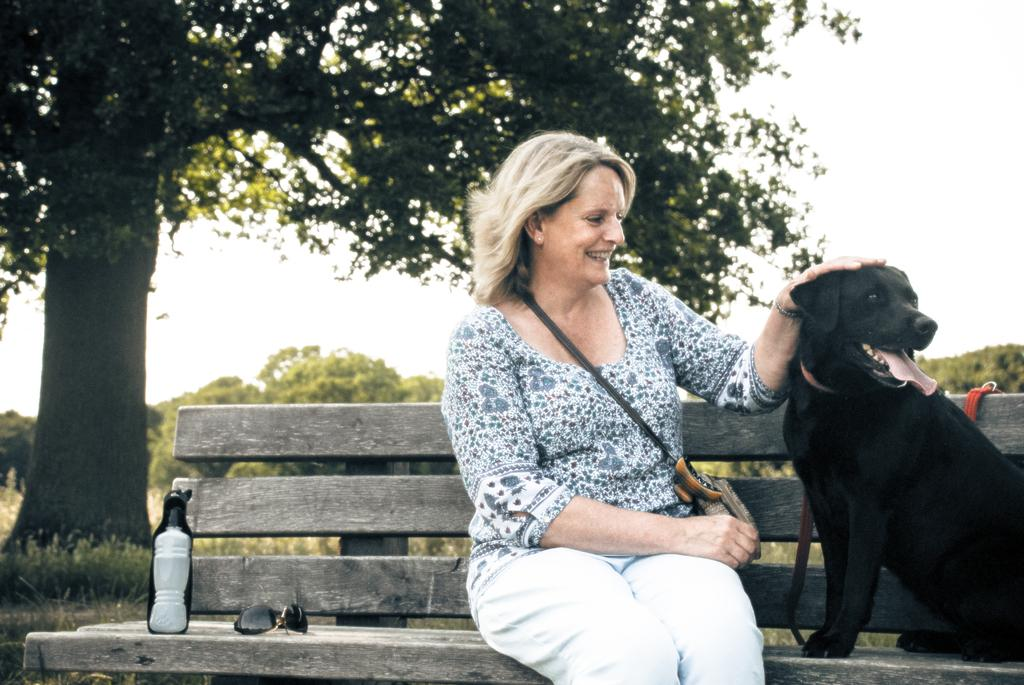Who is present in the image? There is a lady in the image. What is the lady wearing? The lady is wearing a side bag. Where is the lady sitting? The lady is sitting on a bench. What objects are on the bench with the lady? There are spectacles and a bottle on the bench. What animal is sitting on the bench with the lady? There is a dog sitting on the bench. What can be seen in the background of the image? There is a tree and the sky visible in the background of the image. What type of hair is the lady wearing in the image? The facts provided do not mention the lady's hair, so we cannot determine the type of hair she is wearing. How does the star move around in the image? There is no star present in the image, so we cannot determine how it would move. 